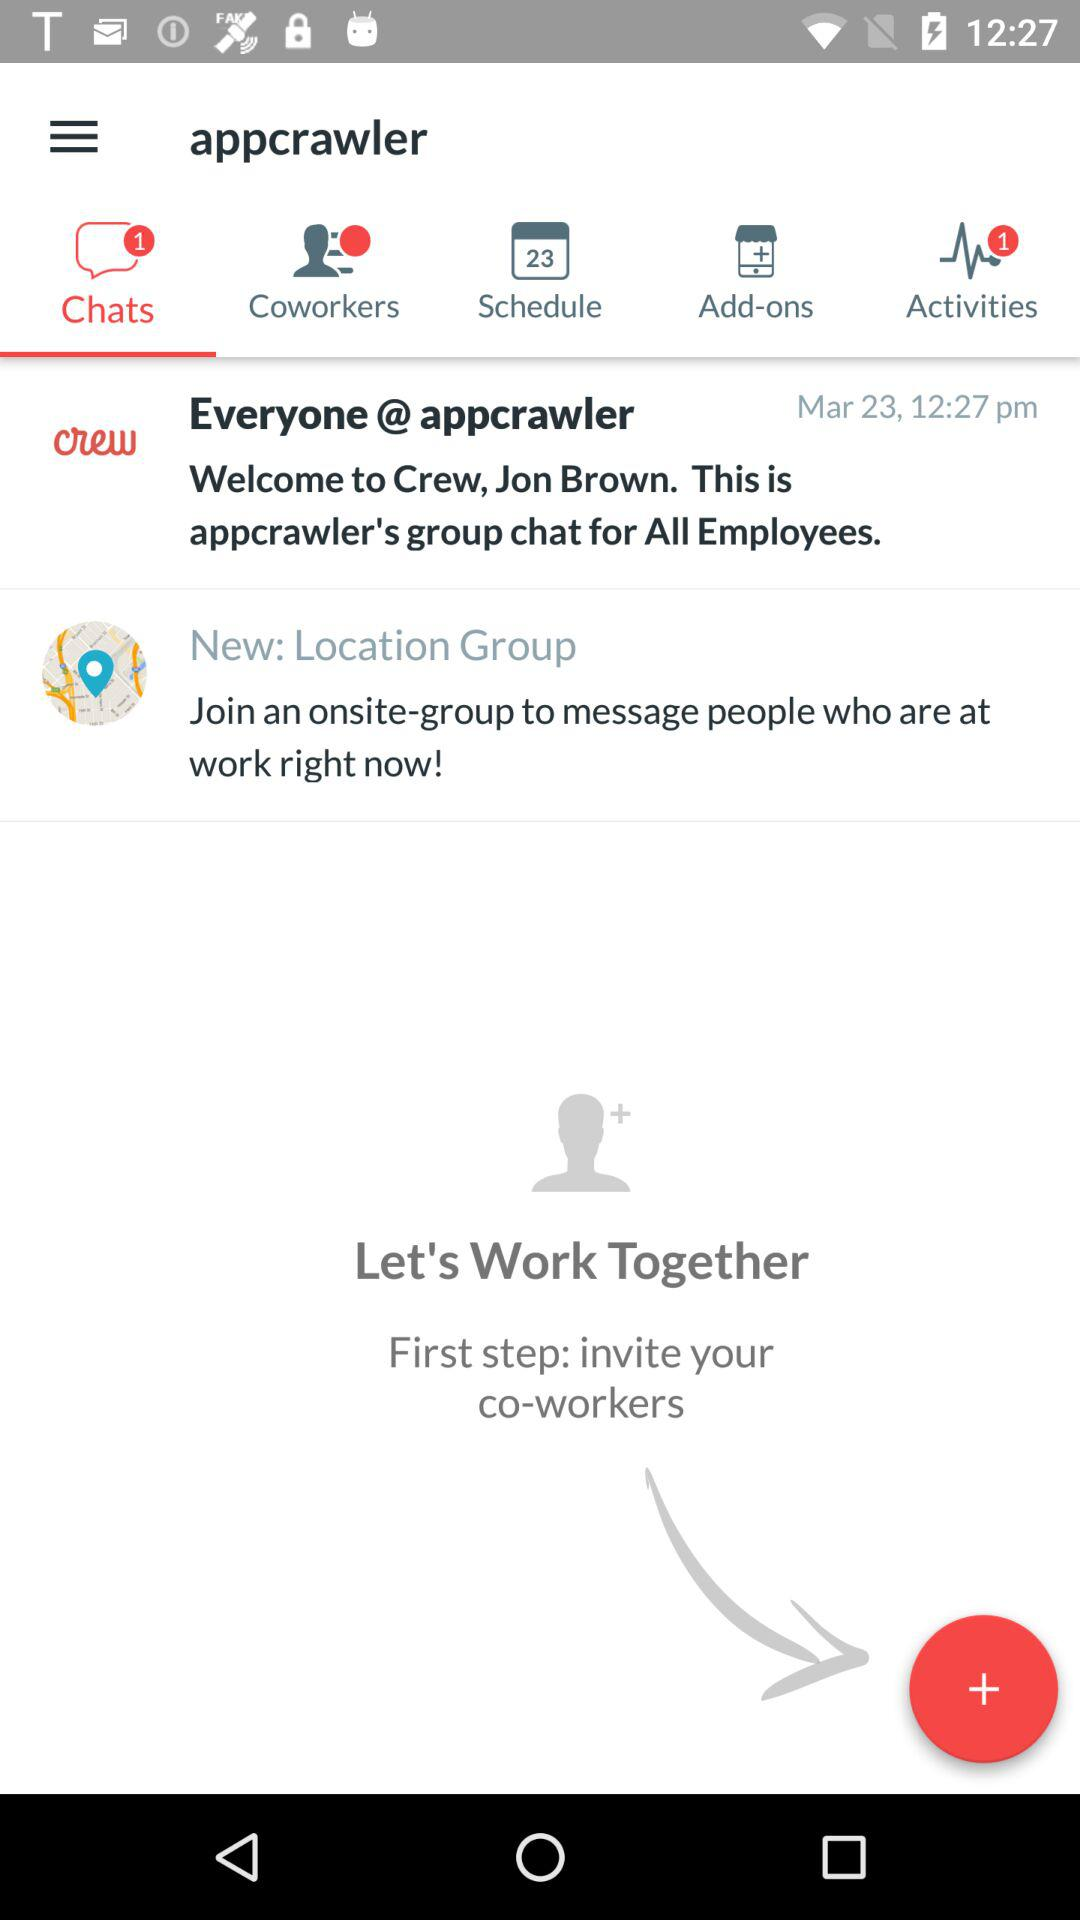What is the mentioned date and time? The mentioned date is March 23 and the time is 12:27 p.m. 